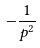Convert formula to latex. <formula><loc_0><loc_0><loc_500><loc_500>- \frac { 1 } { p ^ { 2 } }</formula> 